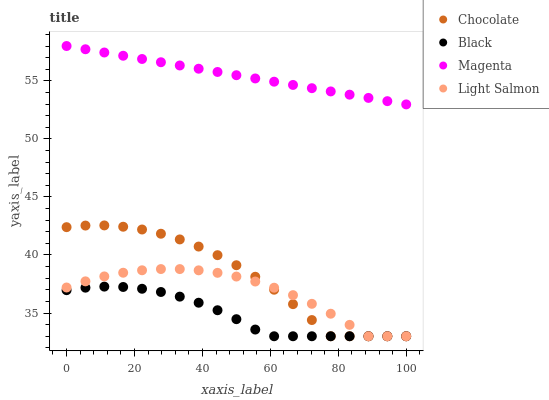Does Black have the minimum area under the curve?
Answer yes or no. Yes. Does Magenta have the maximum area under the curve?
Answer yes or no. Yes. Does Light Salmon have the minimum area under the curve?
Answer yes or no. No. Does Light Salmon have the maximum area under the curve?
Answer yes or no. No. Is Magenta the smoothest?
Answer yes or no. Yes. Is Chocolate the roughest?
Answer yes or no. Yes. Is Black the smoothest?
Answer yes or no. No. Is Black the roughest?
Answer yes or no. No. Does Black have the lowest value?
Answer yes or no. Yes. Does Magenta have the highest value?
Answer yes or no. Yes. Does Light Salmon have the highest value?
Answer yes or no. No. Is Light Salmon less than Magenta?
Answer yes or no. Yes. Is Magenta greater than Light Salmon?
Answer yes or no. Yes. Does Light Salmon intersect Chocolate?
Answer yes or no. Yes. Is Light Salmon less than Chocolate?
Answer yes or no. No. Is Light Salmon greater than Chocolate?
Answer yes or no. No. Does Light Salmon intersect Magenta?
Answer yes or no. No. 